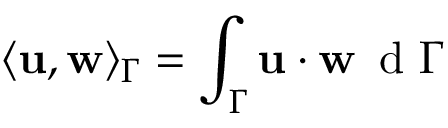Convert formula to latex. <formula><loc_0><loc_0><loc_500><loc_500>\langle { u } , { w } \rangle _ { \Gamma } = \int _ { \Gamma } { u } \cdot { w } \, d \Gamma</formula> 